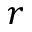<formula> <loc_0><loc_0><loc_500><loc_500>r</formula> 